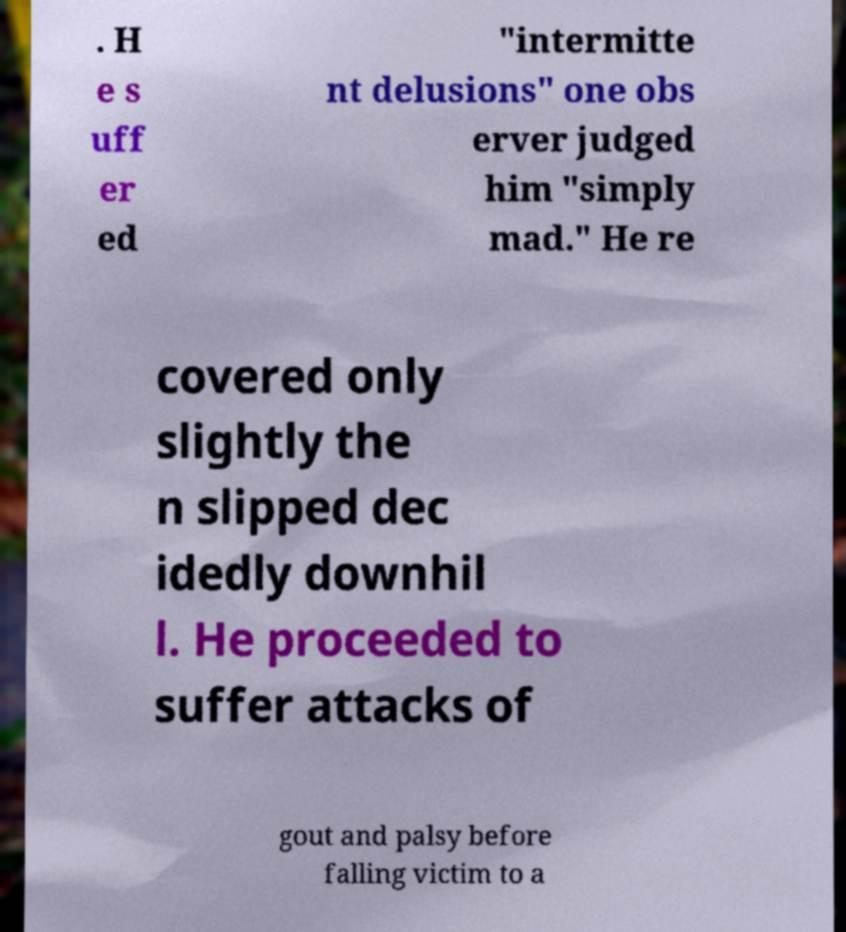Can you read and provide the text displayed in the image?This photo seems to have some interesting text. Can you extract and type it out for me? . H e s uff er ed "intermitte nt delusions" one obs erver judged him "simply mad." He re covered only slightly the n slipped dec idedly downhil l. He proceeded to suffer attacks of gout and palsy before falling victim to a 